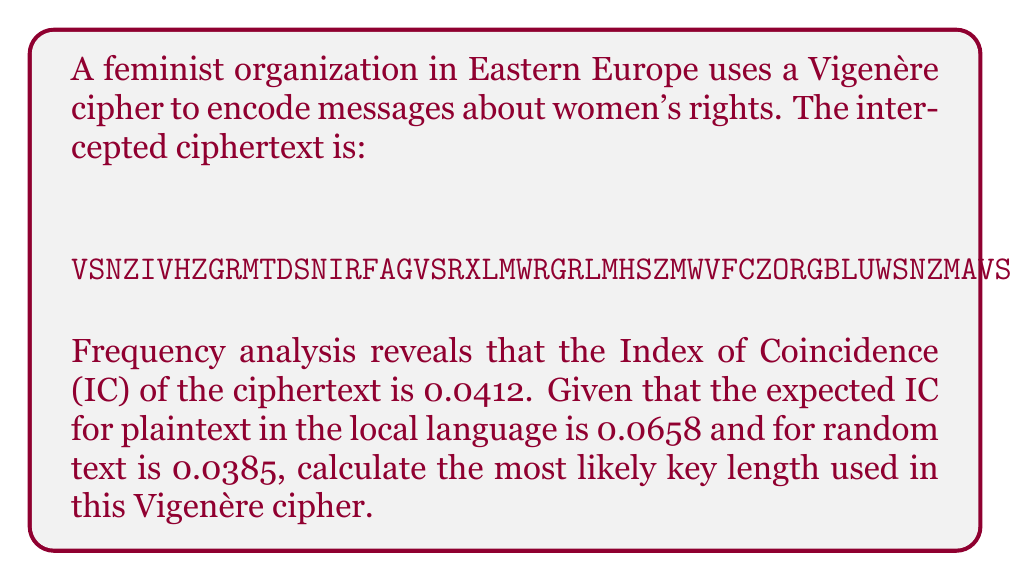Teach me how to tackle this problem. To determine the key length of a Vigenère cipher, we can use the Index of Coincidence (IC) method. The steps are as follows:

1. Calculate the theoretical IC for the key length $n$ using the formula:

   $$IC_n = \frac{1}{n}(IC_{plain} - IC_{random}) + IC_{random}$$

   Where $IC_{plain}$ is the expected IC for plaintext, and $IC_{random}$ is the IC for random text.

2. We're given:
   $IC_{plain} = 0.0658$
   $IC_{random} = 0.0385$
   $IC_{observed} = 0.0412$

3. Let's try different values of $n$ until we find the one that gives us an $IC_n$ closest to the observed IC:

   For $n = 2$:
   $$IC_2 = \frac{1}{2}(0.0658 - 0.0385) + 0.0385 = 0.05215$$

   For $n = 3$:
   $$IC_3 = \frac{1}{3}(0.0658 - 0.0385) + 0.0385 = 0.04760$$

   For $n = 4$:
   $$IC_4 = \frac{1}{4}(0.0658 - 0.0385) + 0.0385 = 0.04532$$

   For $n = 5$:
   $$IC_5 = \frac{1}{5}(0.0658 - 0.0385) + 0.0385 = 0.04426$$

   For $n = 6$:
   $$IC_6 = \frac{1}{6}(0.0658 - 0.0385) + 0.0385 = 0.04355$$

4. The $IC_6 = 0.04355$ is closest to the observed IC of 0.0412.

Therefore, the most likely key length is 6.
Answer: 6 